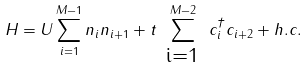Convert formula to latex. <formula><loc_0><loc_0><loc_500><loc_500>H = U \sum _ { i = 1 } ^ { M - 1 } n _ { i } n _ { i + 1 } + t \sum ^ { M - 2 } _ { \substack { \text { i=1 } } } c _ { i } ^ { \dagger } c _ { i + 2 } + h . c .</formula> 